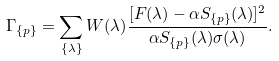Convert formula to latex. <formula><loc_0><loc_0><loc_500><loc_500>\Gamma _ { \{ p \} } = \sum _ { \{ \lambda \} } { W ( \lambda ) \frac { [ F ( \lambda ) - { \alpha } S _ { \{ p \} } ( \lambda ) ] ^ { 2 } } { { \alpha } S _ { \{ p \} } ( \lambda ) \sigma ( \lambda ) } } .</formula> 